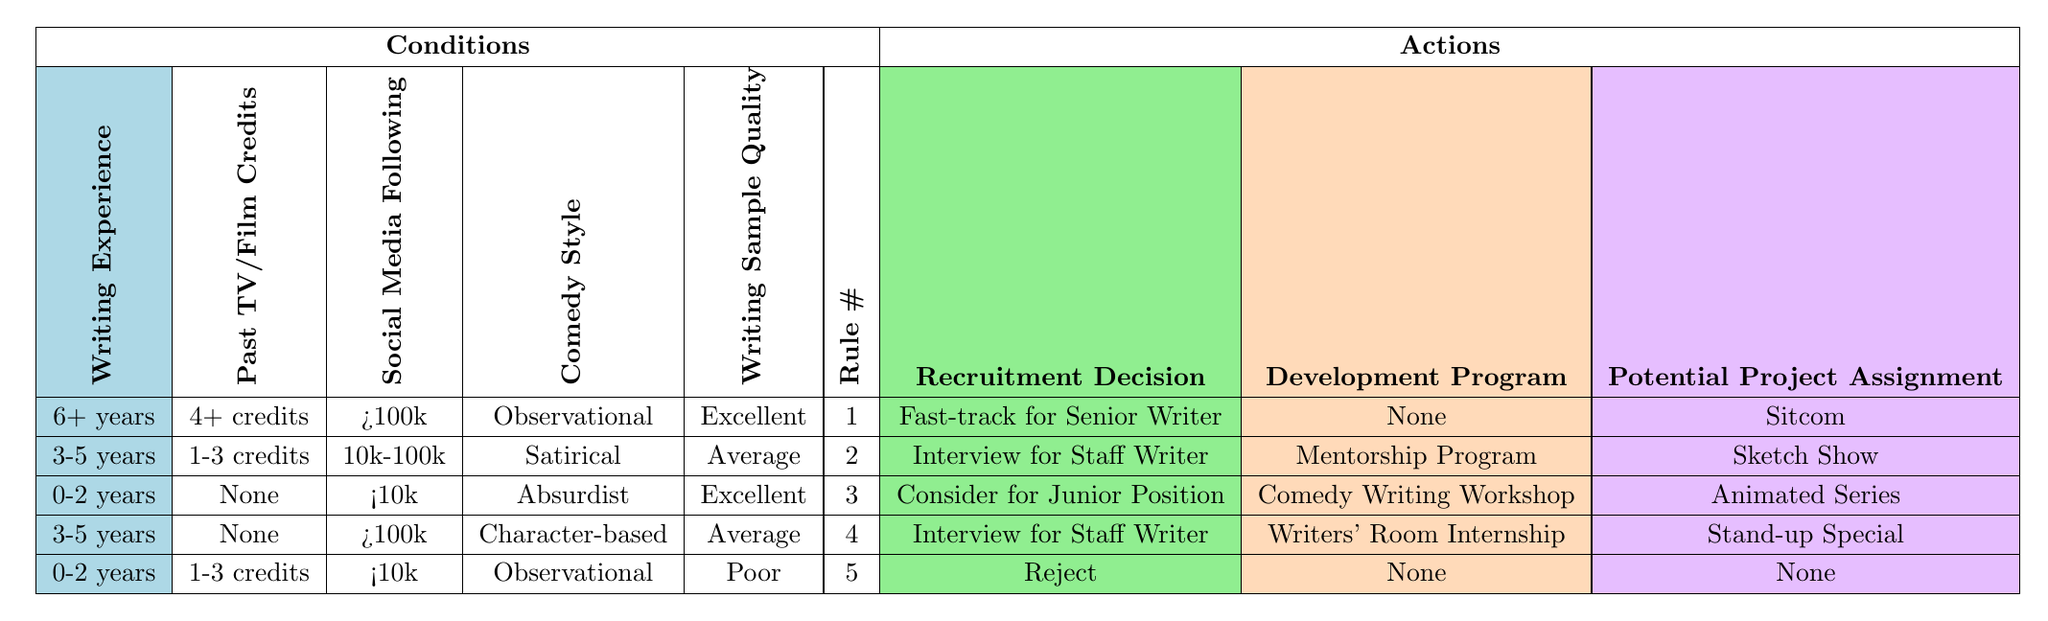What is the recruitment decision for a candidate with 0-2 years of writing experience, no past TV/Film credits, and an excellent writing sample quality? According to the table, under these conditions, the recruitment decision is to "Consider for Junior Position."
Answer: Consider for Junior Position What development program is recommended for a candidate with 3-5 years of writing experience, 1-3 past TV/Film credits, and a satirical comedy style? The table indicates that this profile receives a "Mentorship Program" as the development program option.
Answer: Mentorship Program Is there any candidate with 0-2 years of writing experience who gets fast-tracked for a senior writer position? The table shows no candidates with 0-2 years of experience receiving a fast-track decision; the minimum experience for fast-track is 6+ years.
Answer: No What is the potential project assignment for a candidate with a comedic style that is observational and has 4 or more past TV/Film credits? In the table, the only candidate with a comedic style of observational and 4+ past TV/Film credits is associated with a sitcom as the potential project assignment.
Answer: Sitcom If we consider candidates with 3-5 years of experience, what is the average recruitment decision? There are two candidates with 3-5 years of experience. Their decisions are "Interview for Staff Writer," and the average decision would be categorized as "Interview for Staff Writer" since it is the most frequent outcome.
Answer: Interview for Staff Writer What is the social media following of the candidate who is being rejected based on their writing sample quality? The table indicates that the candidate being rejected has "<10k" social media followers.
Answer: <10k Are there more candidates suggested for mentorship programs compared to those receiving comedy writing workshops? There are two candidates suggested for mentorship programs and one for a comedy writing workshop, which means there are more candidates in the mentorship program.
Answer: Yes What comedy style is associated with the candidate being interviewed for a staff writer position with 3-5 years of experience? The table specifies that the comedy style for the candidate interviewed for a staff writer position with 3-5 years of experience is "Satirical."
Answer: Satirical How many candidates with poor writing sample quality are suggested for any development program? The table only shows one candidate with poor writing sample quality who is recommended for no development program. Hence, the answer is that zero candidates are suggested for any development program in this case.
Answer: Zero 